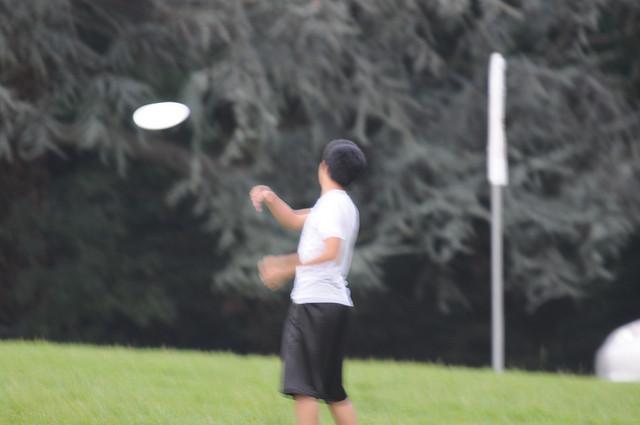Is this picture clear?
Answer briefly. No. Why is the boy not in focus?
Be succinct. Moving. What game is being played?
Keep it brief. Frisbee. What is flying through the air?
Write a very short answer. Frisbee. 